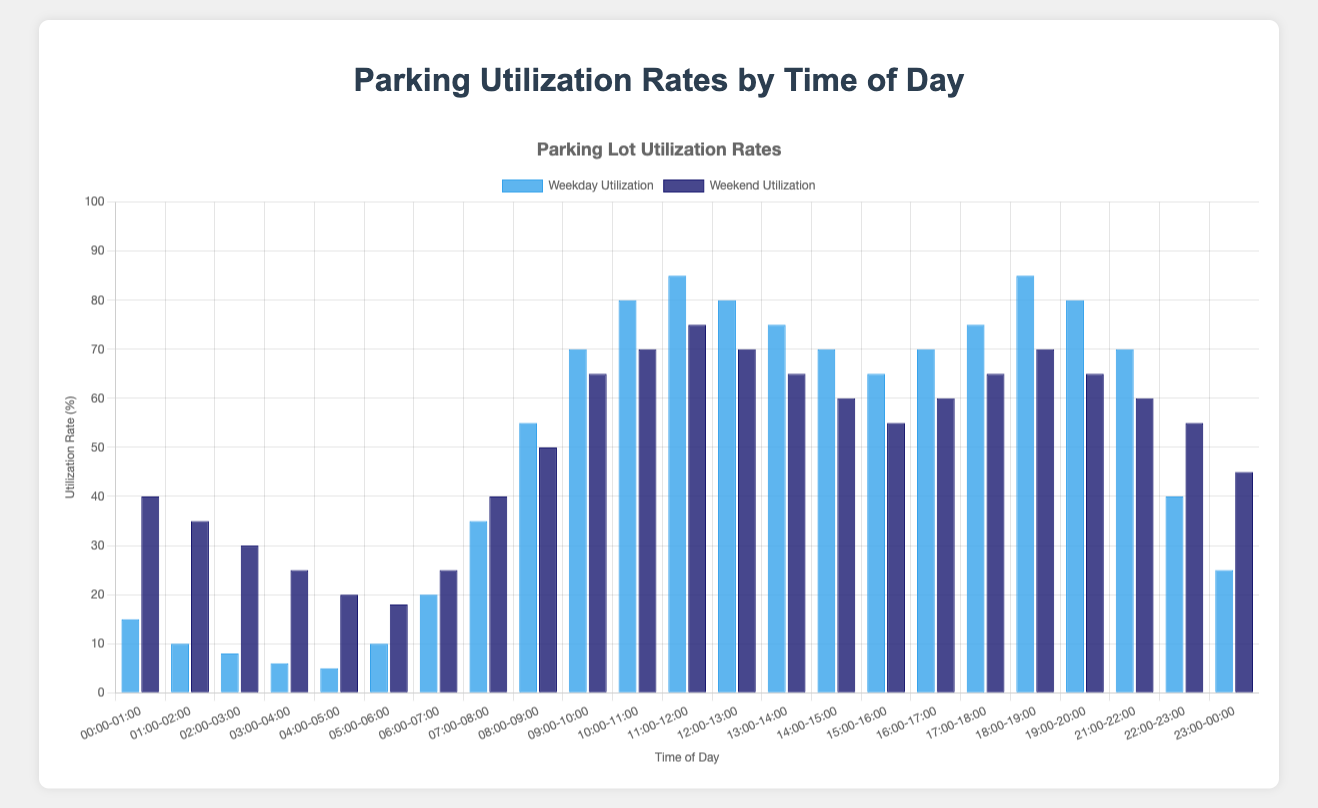What time of day has the highest weekday utilization rate? The bar height for each time slot on weekdays shows the utilization rates. The 11:00-12:00 slot has the highest weekday utilization rate.
Answer: 11:00-12:00 Which period shows the most significant difference in utilization between weekdays and weekends, and what is the difference? The blue and dark blue bars for each time slot are compared, and the largest difference is observed between 00:00-01:00 with a difference of 25%.
Answer: 00:00-01:00, 25% What's the average utilization rate across all time slots for weekends? Sum all the weekend utilization rates and divide by the number of time slots: (40+35+30+25+20+18+25+40+50+65+70+75+70+65+60+55+60+65+70+65+60+55+45)/23 = 800/23 ≈ 34.78
Answer: ~34.78% Which time slot has the lowest utilization rate on weekdays, and what is that rate? Referring to the lowest bar for weekday data, the time slot 04:00-05:00 has the lowest utilization rate of 5%.
Answer: 04:00-05:00, 5% During which time slots is the weekday utilization rate greater than or equal to 70%? Identify the bars with a weekday utilization rate of 70% or more: 09:00-10:00, 10:00-11:00, 11:00-12:00, 12:00-13:00, 13:00-14:00, 14:00-15:00, 18:00-19:00
Answer: 09:00-10:00, 10:00-11:00, 11:00-12:00, 12:00-13:00, 13:00-14:00, 14:00-15:00, 18:00-19:00 What is the total utilization rate from 06:00-12:00 on weekends? Sum the weekend utilization rates from 06:00 to 12:00: 25+40+50+65+70+75 = 325
Answer: 325% Which hour shows the biggest increase in utilization from weekday to weekend rates? Compare each slot's weekday and weekend bar heights, and the largest increase is from 00:00-01:00, moving from 15% to 40%.
Answer: 00:00-01:00 When is the weekend utilization rate higher than the weekday rate? Compare each slot's weekday and weekend bars; 00:00-01:00, 01:00-02:00, 02:00-03:00, 03:00-04:00, 04:00-05:00, 22:00-23:00, and 23:00-00:00 show higher weekend rates.
Answer: 00:00-01:00, 01:00-02:00, 02:00-03:00, 03:00-04:00, 04:00-05:00, 22:00-23:00, 23:00-00:00 